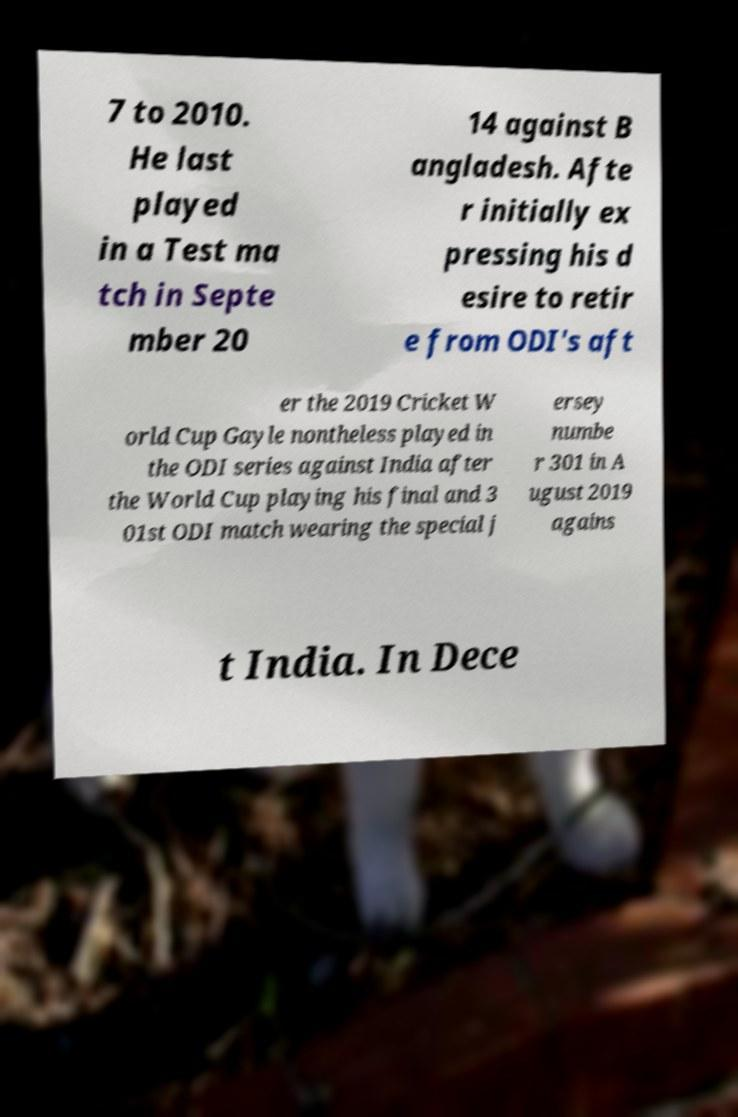For documentation purposes, I need the text within this image transcribed. Could you provide that? 7 to 2010. He last played in a Test ma tch in Septe mber 20 14 against B angladesh. Afte r initially ex pressing his d esire to retir e from ODI's aft er the 2019 Cricket W orld Cup Gayle nontheless played in the ODI series against India after the World Cup playing his final and 3 01st ODI match wearing the special j ersey numbe r 301 in A ugust 2019 agains t India. In Dece 